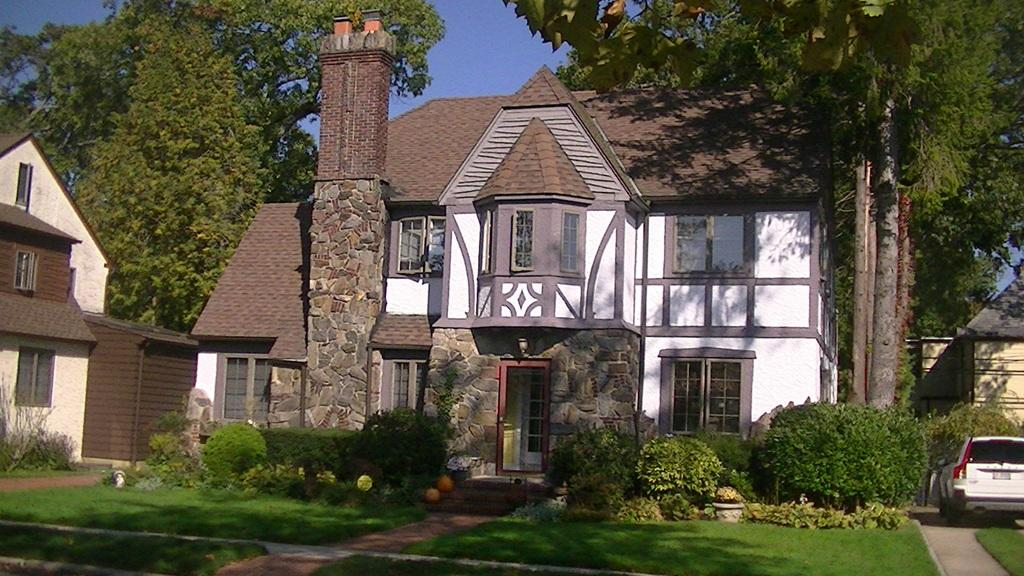What type of structures can be seen in the image? There are houses in the image. What type of vegetation is present in the image? There are trees and grass in the image. Where is the car located in the image? The car is parked on the right side of the image. What is visible in the background of the image? The sky is visible in the image. How does the hose maintain its balance in the image? There is no hose present in the image, so the question of balance is not applicable. 